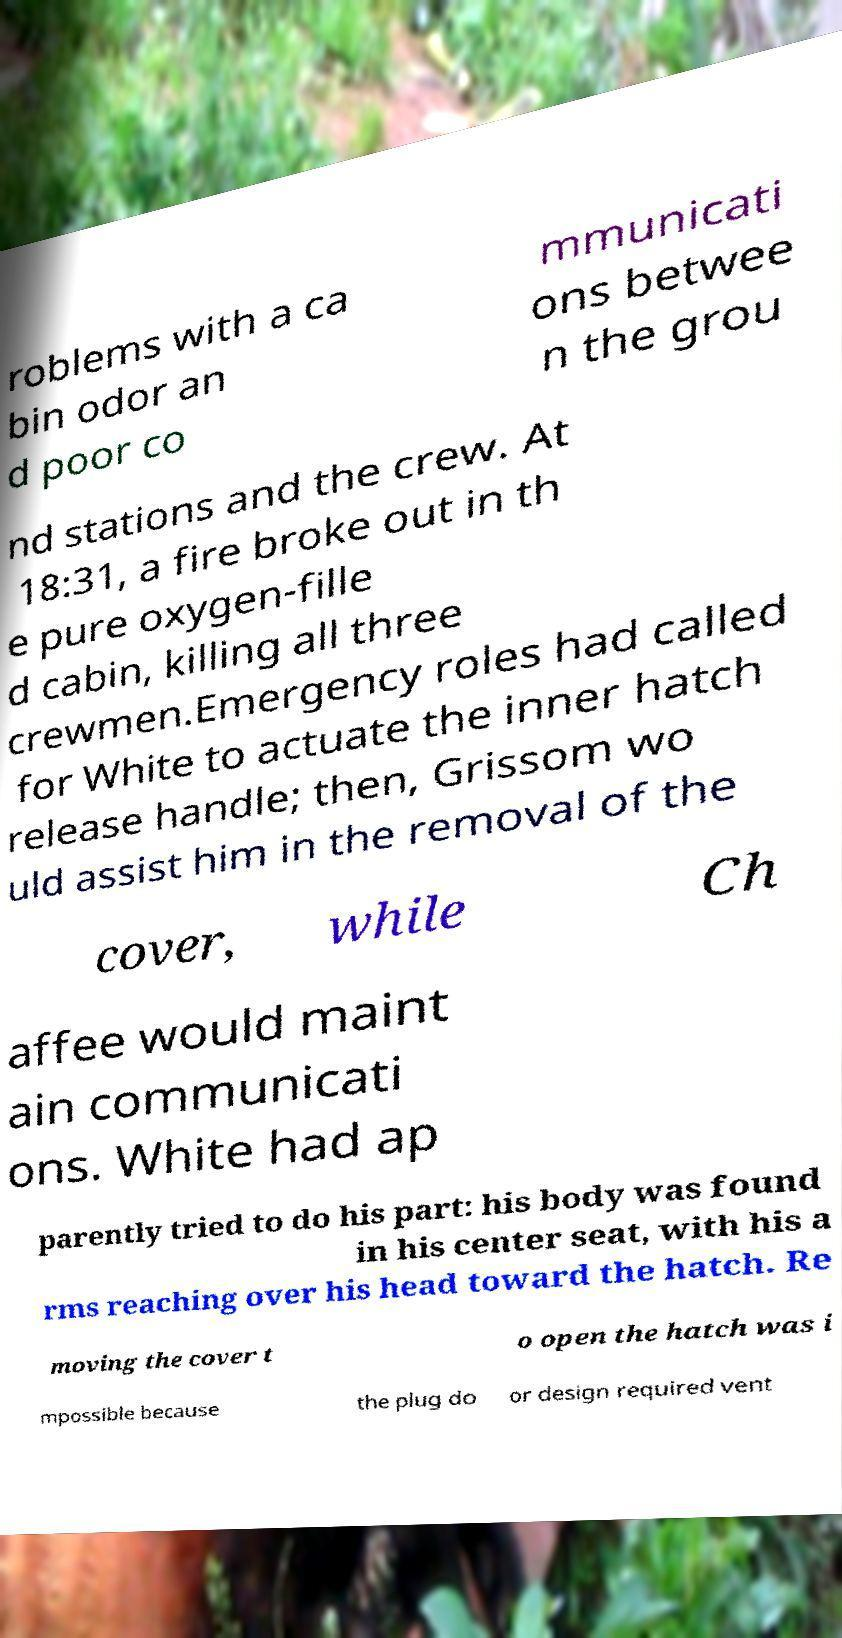Please read and relay the text visible in this image. What does it say? roblems with a ca bin odor an d poor co mmunicati ons betwee n the grou nd stations and the crew. At 18:31, a fire broke out in th e pure oxygen-fille d cabin, killing all three crewmen.Emergency roles had called for White to actuate the inner hatch release handle; then, Grissom wo uld assist him in the removal of the cover, while Ch affee would maint ain communicati ons. White had ap parently tried to do his part: his body was found in his center seat, with his a rms reaching over his head toward the hatch. Re moving the cover t o open the hatch was i mpossible because the plug do or design required vent 